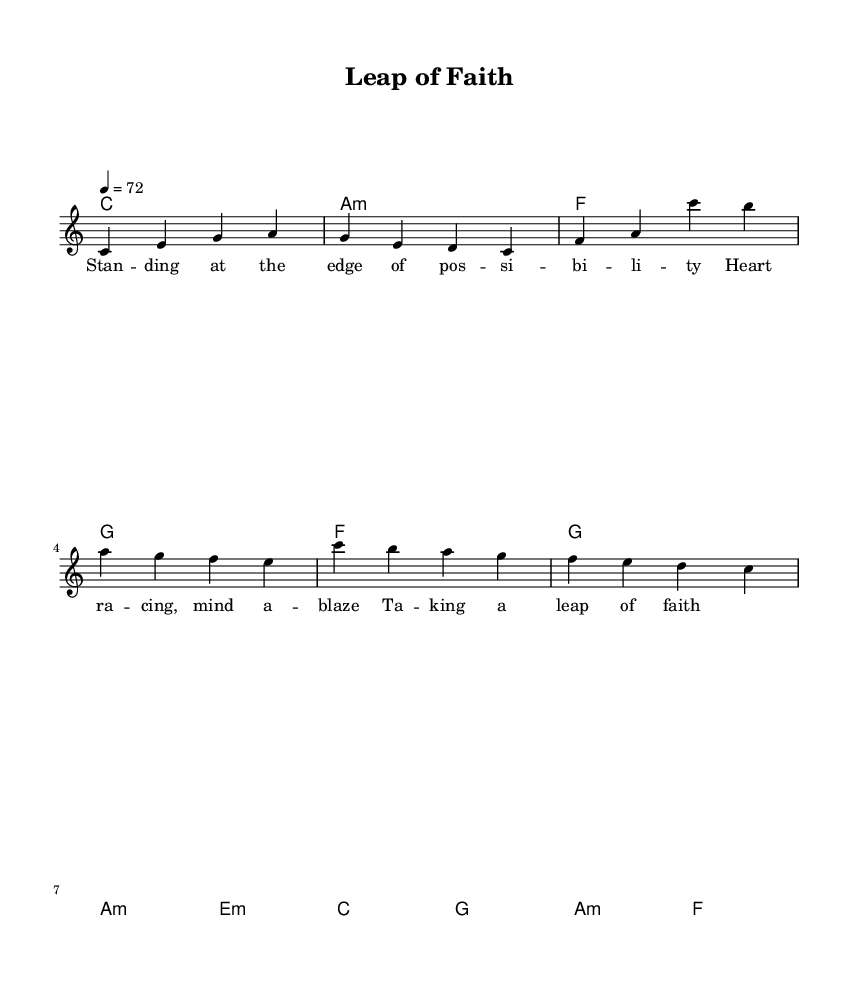What is the key signature of this music? The key signature is C major, which has no sharps or flats.
Answer: C major What is the time signature of this music? The time signature is indicated at the beginning of the score and shows how many beats are in each measure; here, it's 4 beats per measure.
Answer: 4/4 What is the tempo marking for this piece? The tempo marking indicates the speed of the piece; in this case, it is set to 72 beats per minute.
Answer: 72 What are the chords for the chorus section? The chords for the chorus section can be found in the chord mode labeled "Chorus," which specifies c, g, a minor, and f.
Answer: c, g, a minor, f How many measures are in the verse? The verse consists of 4 measures as indicated by the sequence of notes and corresponding chords that are listed together.
Answer: 4 What is the emotional theme explored in the lyrics? Analyzing the lyrics provided in the lyric mode reveals a theme concerning taking risks and the tension associated with entrepreneurship, described vividly in the text.
Answer: Taking a leap of faith Which section contains the most harmonic complexity? The pre-chorus typically offers different chords that build tension before the chorus, represented by the progression in the harmonies specifically labeled "Pre-Chorus."
Answer: Pre-Chorus 